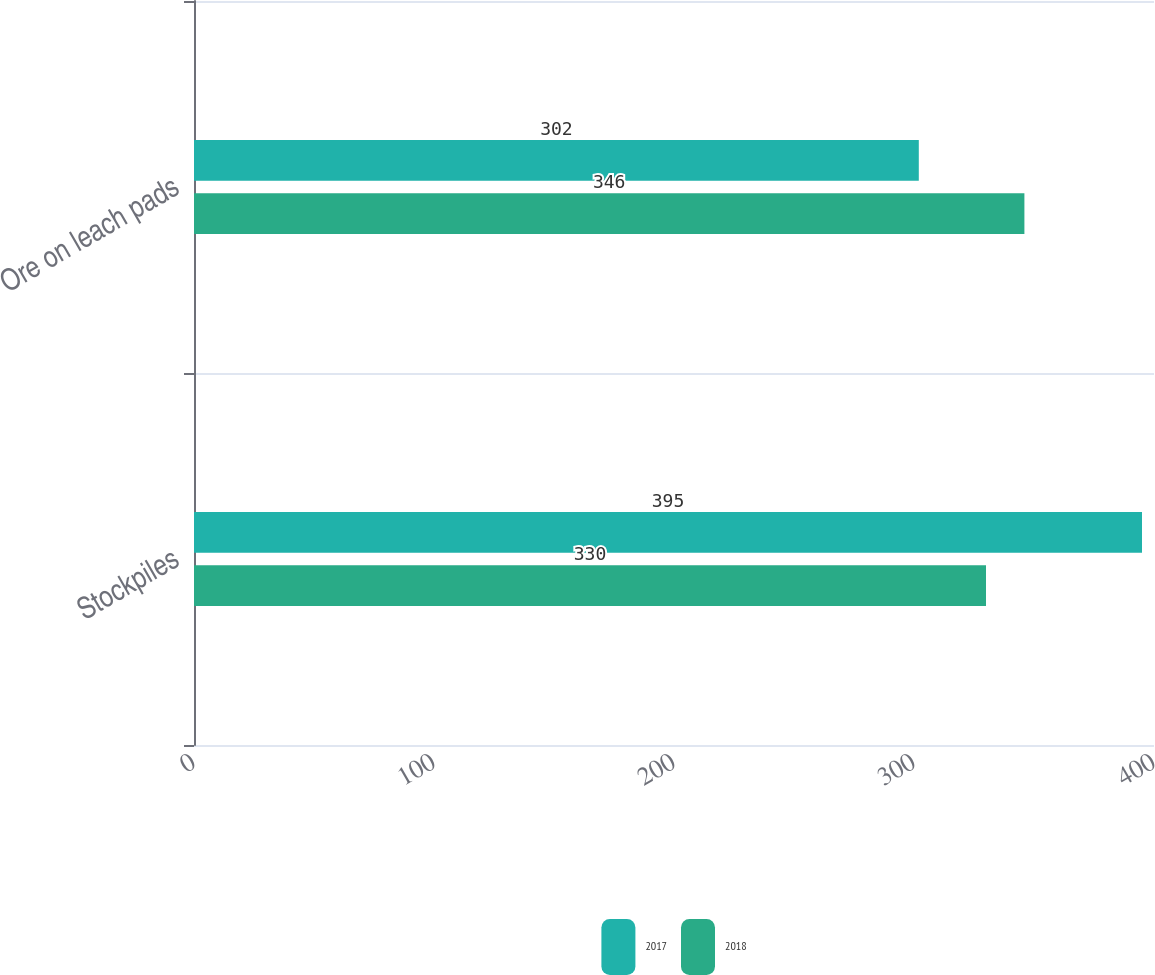Convert chart. <chart><loc_0><loc_0><loc_500><loc_500><stacked_bar_chart><ecel><fcel>Stockpiles<fcel>Ore on leach pads<nl><fcel>2017<fcel>395<fcel>302<nl><fcel>2018<fcel>330<fcel>346<nl></chart> 